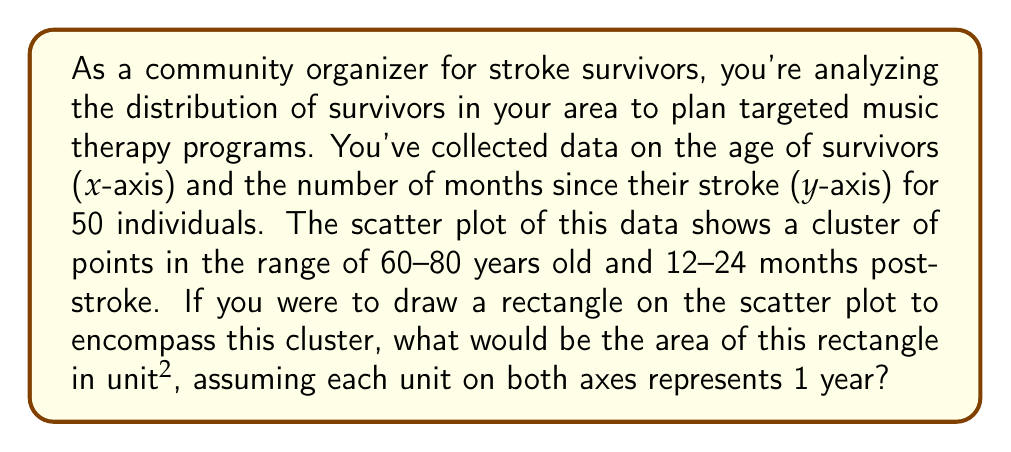Solve this math problem. To solve this problem, we need to follow these steps:

1. Identify the range of the cluster on both axes:
   - x-axis (age): 60 to 80 years
   - y-axis (months since stroke): 12 to 24 months

2. Convert the y-axis range to years for consistency:
   - 12 months = 1 year
   - 24 months = 2 years

3. Calculate the dimensions of the rectangle:
   - Width (age range): $80 - 60 = 20$ years
   - Height (time since stroke range): $2 - 1 = 1$ year

4. Calculate the area of the rectangle:
   Area = width × height
   $$ A = 20 \times 1 = 20 \text{ unit}^2 $$

Each unit represents 1 year on both axes, so the area is in year^2 or unit^2.

This rectangle encompasses the main cluster of stroke survivors, indicating that most survivors in your community are between 60-80 years old and had their stroke 1-2 years ago. This information can help you tailor your music therapy programs to the needs of this specific group.
Answer: $20 \text{ unit}^2$ 